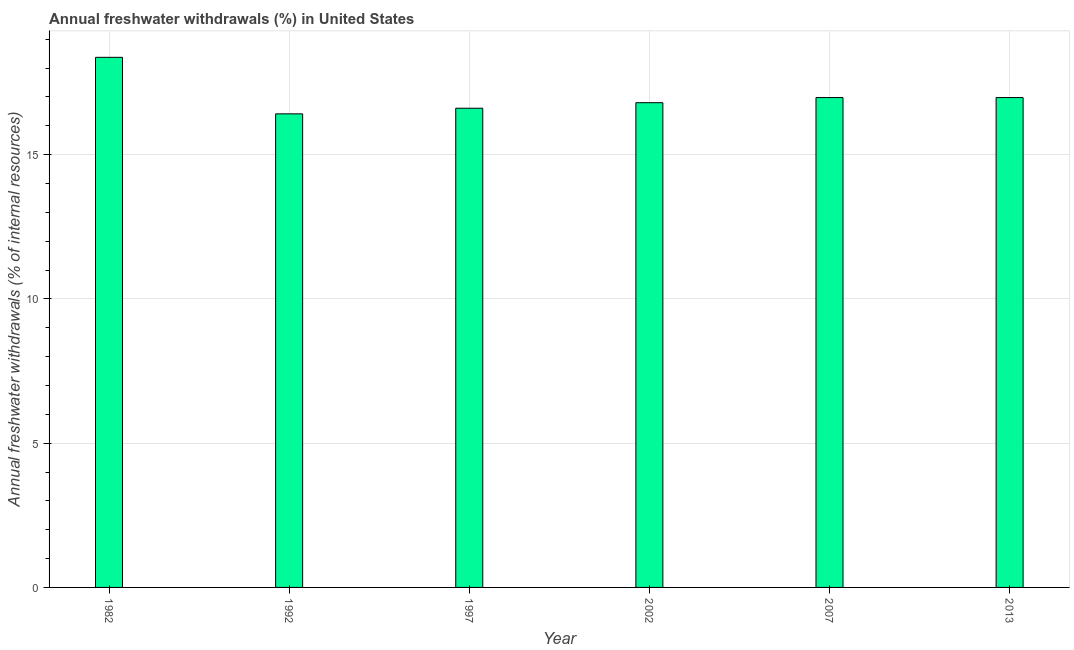Does the graph contain any zero values?
Provide a succinct answer. No. What is the title of the graph?
Offer a terse response. Annual freshwater withdrawals (%) in United States. What is the label or title of the X-axis?
Give a very brief answer. Year. What is the label or title of the Y-axis?
Offer a very short reply. Annual freshwater withdrawals (% of internal resources). What is the annual freshwater withdrawals in 2007?
Make the answer very short. 16.98. Across all years, what is the maximum annual freshwater withdrawals?
Your response must be concise. 18.37. Across all years, what is the minimum annual freshwater withdrawals?
Offer a terse response. 16.41. In which year was the annual freshwater withdrawals minimum?
Your answer should be very brief. 1992. What is the sum of the annual freshwater withdrawals?
Give a very brief answer. 102.14. What is the difference between the annual freshwater withdrawals in 2007 and 2013?
Your answer should be compact. 0. What is the average annual freshwater withdrawals per year?
Your answer should be compact. 17.02. What is the median annual freshwater withdrawals?
Keep it short and to the point. 16.89. Do a majority of the years between 1992 and 1997 (inclusive) have annual freshwater withdrawals greater than 2 %?
Give a very brief answer. Yes. What is the ratio of the annual freshwater withdrawals in 1992 to that in 2002?
Offer a terse response. 0.98. Is the annual freshwater withdrawals in 1992 less than that in 2002?
Your answer should be compact. Yes. What is the difference between the highest and the second highest annual freshwater withdrawals?
Your answer should be very brief. 1.4. Is the sum of the annual freshwater withdrawals in 1982 and 1992 greater than the maximum annual freshwater withdrawals across all years?
Your answer should be very brief. Yes. What is the difference between the highest and the lowest annual freshwater withdrawals?
Your response must be concise. 1.96. Are all the bars in the graph horizontal?
Your response must be concise. No. How many years are there in the graph?
Your response must be concise. 6. What is the difference between two consecutive major ticks on the Y-axis?
Your answer should be compact. 5. What is the Annual freshwater withdrawals (% of internal resources) in 1982?
Offer a very short reply. 18.37. What is the Annual freshwater withdrawals (% of internal resources) in 1992?
Give a very brief answer. 16.41. What is the Annual freshwater withdrawals (% of internal resources) in 1997?
Your response must be concise. 16.61. What is the Annual freshwater withdrawals (% of internal resources) of 2002?
Give a very brief answer. 16.8. What is the Annual freshwater withdrawals (% of internal resources) of 2007?
Provide a succinct answer. 16.98. What is the Annual freshwater withdrawals (% of internal resources) of 2013?
Your response must be concise. 16.98. What is the difference between the Annual freshwater withdrawals (% of internal resources) in 1982 and 1992?
Offer a very short reply. 1.96. What is the difference between the Annual freshwater withdrawals (% of internal resources) in 1982 and 1997?
Offer a terse response. 1.76. What is the difference between the Annual freshwater withdrawals (% of internal resources) in 1982 and 2002?
Provide a short and direct response. 1.57. What is the difference between the Annual freshwater withdrawals (% of internal resources) in 1982 and 2007?
Your answer should be compact. 1.39. What is the difference between the Annual freshwater withdrawals (% of internal resources) in 1982 and 2013?
Make the answer very short. 1.39. What is the difference between the Annual freshwater withdrawals (% of internal resources) in 1992 and 1997?
Provide a succinct answer. -0.2. What is the difference between the Annual freshwater withdrawals (% of internal resources) in 1992 and 2002?
Provide a succinct answer. -0.39. What is the difference between the Annual freshwater withdrawals (% of internal resources) in 1992 and 2007?
Your answer should be compact. -0.56. What is the difference between the Annual freshwater withdrawals (% of internal resources) in 1992 and 2013?
Provide a succinct answer. -0.56. What is the difference between the Annual freshwater withdrawals (% of internal resources) in 1997 and 2002?
Your answer should be compact. -0.19. What is the difference between the Annual freshwater withdrawals (% of internal resources) in 1997 and 2007?
Offer a very short reply. -0.37. What is the difference between the Annual freshwater withdrawals (% of internal resources) in 1997 and 2013?
Provide a short and direct response. -0.37. What is the difference between the Annual freshwater withdrawals (% of internal resources) in 2002 and 2007?
Give a very brief answer. -0.18. What is the difference between the Annual freshwater withdrawals (% of internal resources) in 2002 and 2013?
Offer a very short reply. -0.18. What is the ratio of the Annual freshwater withdrawals (% of internal resources) in 1982 to that in 1992?
Make the answer very short. 1.12. What is the ratio of the Annual freshwater withdrawals (% of internal resources) in 1982 to that in 1997?
Make the answer very short. 1.11. What is the ratio of the Annual freshwater withdrawals (% of internal resources) in 1982 to that in 2002?
Give a very brief answer. 1.09. What is the ratio of the Annual freshwater withdrawals (% of internal resources) in 1982 to that in 2007?
Keep it short and to the point. 1.08. What is the ratio of the Annual freshwater withdrawals (% of internal resources) in 1982 to that in 2013?
Your answer should be very brief. 1.08. What is the ratio of the Annual freshwater withdrawals (% of internal resources) in 1992 to that in 1997?
Offer a very short reply. 0.99. What is the ratio of the Annual freshwater withdrawals (% of internal resources) in 1992 to that in 2002?
Your response must be concise. 0.98. What is the ratio of the Annual freshwater withdrawals (% of internal resources) in 1992 to that in 2013?
Your answer should be very brief. 0.97. What is the ratio of the Annual freshwater withdrawals (% of internal resources) in 1997 to that in 2013?
Make the answer very short. 0.98. What is the ratio of the Annual freshwater withdrawals (% of internal resources) in 2002 to that in 2007?
Your answer should be compact. 0.99. What is the ratio of the Annual freshwater withdrawals (% of internal resources) in 2002 to that in 2013?
Give a very brief answer. 0.99. What is the ratio of the Annual freshwater withdrawals (% of internal resources) in 2007 to that in 2013?
Your answer should be compact. 1. 